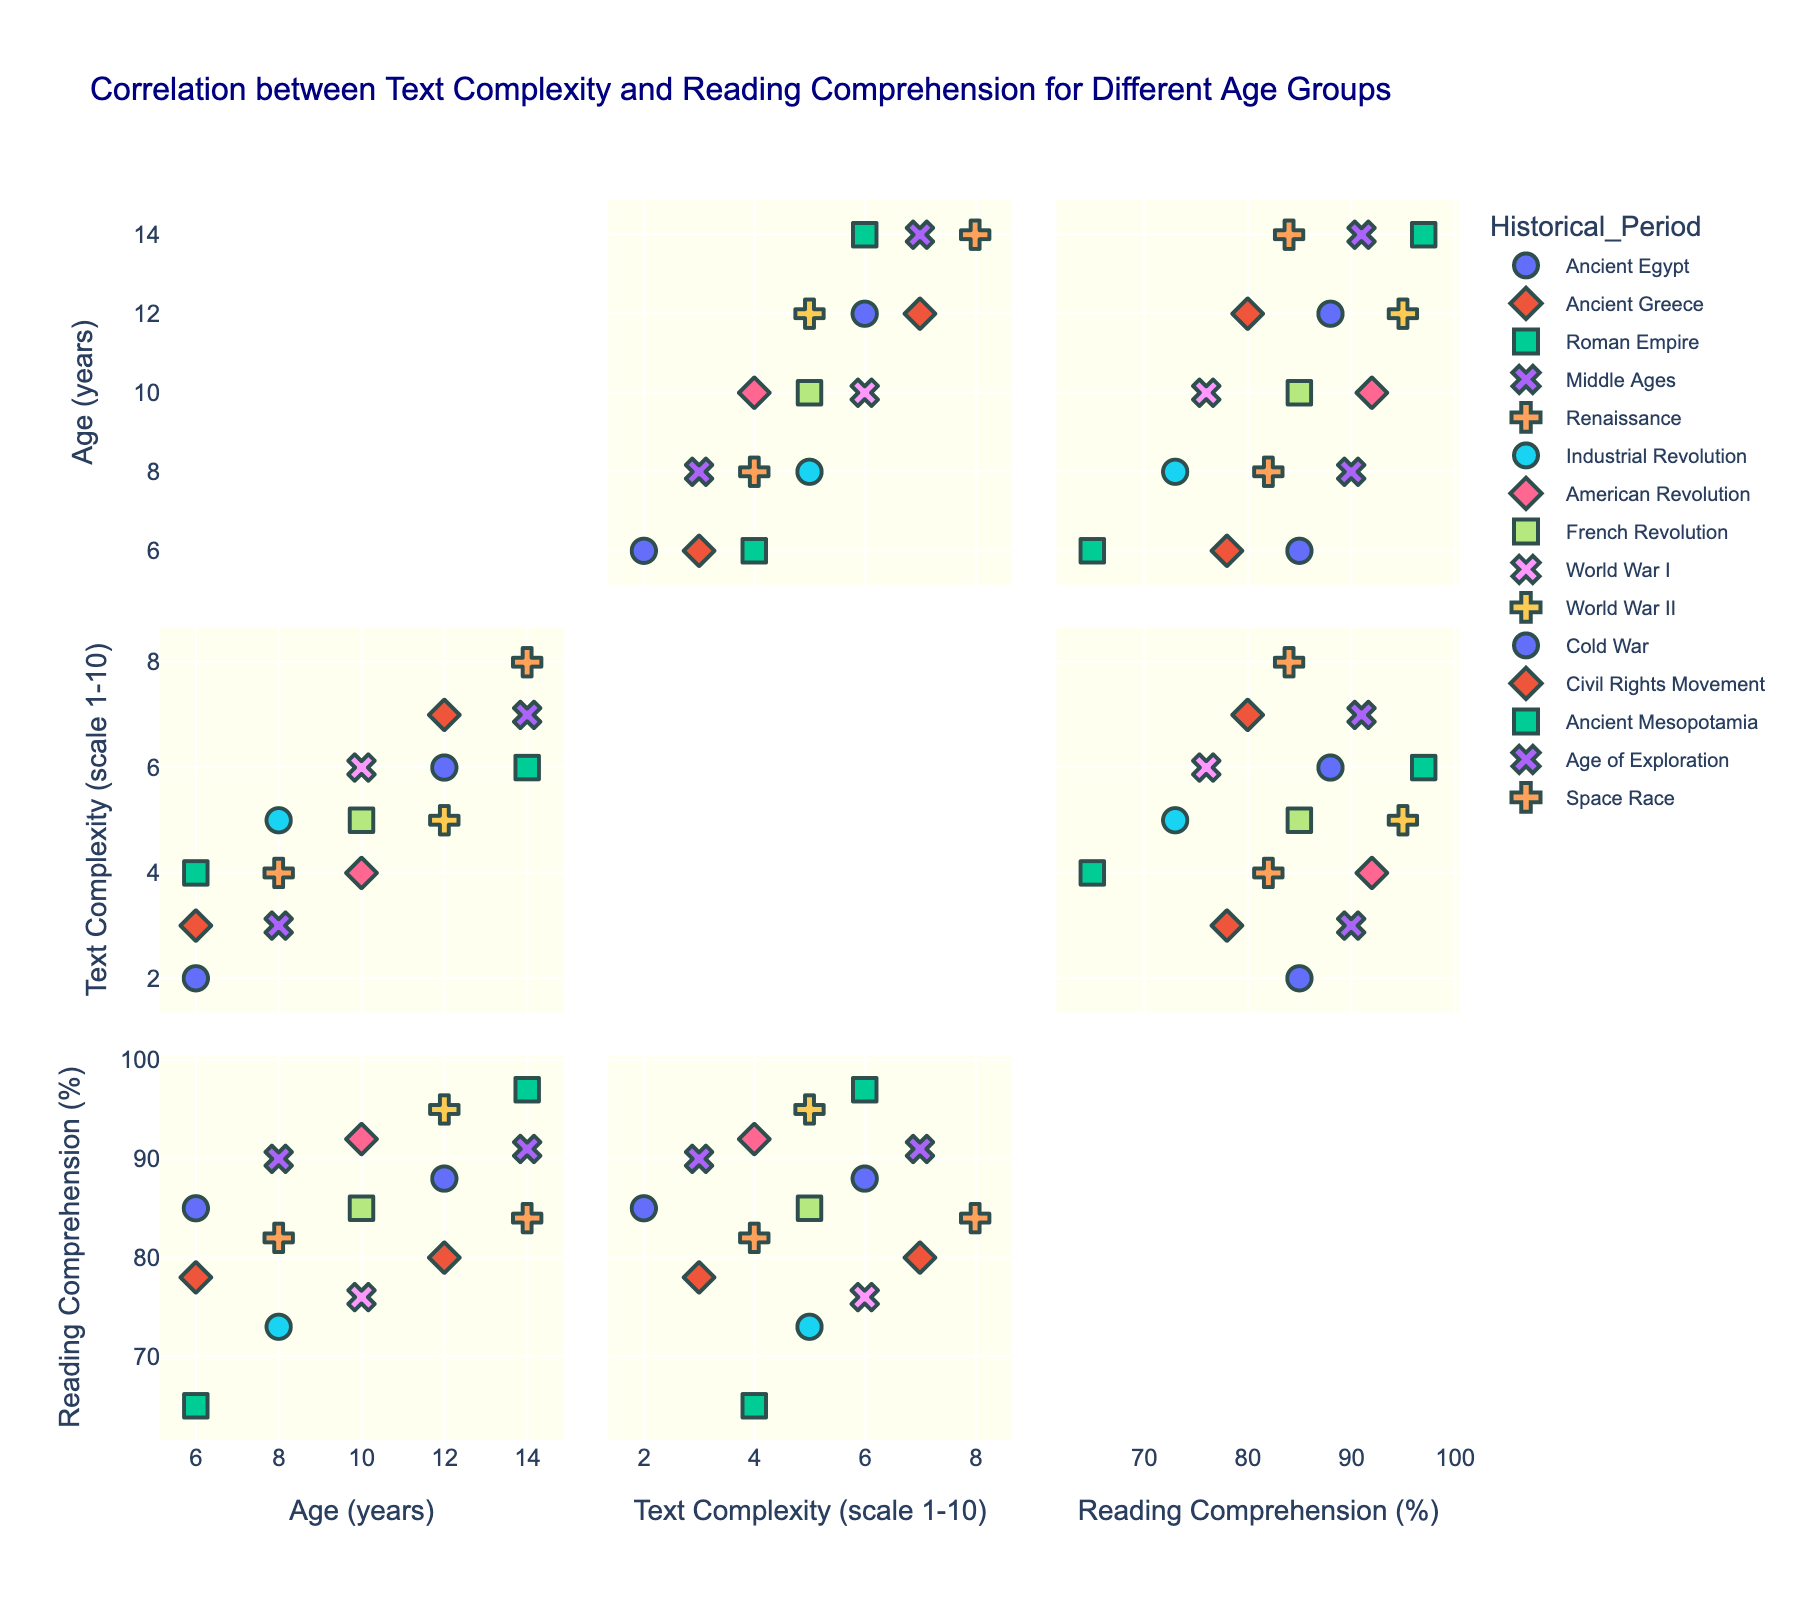How many different historical periods are displayed in the scatterplot matrix? By analyzing the legend or the markers in the scatterplot matrix, we can count the unique historical periods.
Answer: 12 Which age group has the highest average text complexity? To determine this, we need to find the average text complexity for each age group listed in the data and compare these averages. The sums of text complexity for ages 6, 8, 10, 12, and 14 are 9, 12, 15, 18, and 21 respectively. Dividing by the number of data points (3 for each age group), we get averages of 3, 4, 5, 6, and 7 respectively. The highest average is for age 14.
Answer: 14 Is there a trend between text complexity and reading comprehension as age increases? Observing the scatterplot matrix, we can see if there's an upward or downward trend in reading comprehension with respect to text complexity for different ages. Generally, as age increases, both text complexity and reading comprehension appear to increase.
Answer: Yes, both increase Which historical period is associated with the highest reading comprehension score? By examining the specific markers in the scatterplot matrix that represent the reading comprehension scores, we find the highest reading comprehension value and identify the corresponding historical period in the legend.
Answer: Ancient Mesopotamia What is the range of reading comprehension scores for age 8? The range can be found by identifying the highest and lowest reading comprehension scores for the age 8 group, then calculating the difference. The scores for age 8 are 90, 82, and 73, so the range is 90 - 73.
Answer: 17 How does the reading comprehension for the Industrial Revolution compare to the Space Race? By locating both historical periods in the scatterplot matrix and comparing their reading comprehension values, we find the values for Industrial Revolution (73) and Space Race (84).
Answer: Space Race is higher Do text complexity and reading comprehension always increase together for each age? By examining the scatterplot points and looking at the combinations of text complexity and reading comprehension scores for each age, we can assess if they consistently increase together. For example, ages 8 and 12 show an increase in both, but ages 10 and 14 do not always increase at the same rate.
Answer: No What is the average reading comprehension score for age 10? The scores for age 10 are 92, 85, and 76. Adding these up gives 253, and dividing by 3 gives an average of 253 / 3.
Answer: 84.33 Which age group shows the greatest variance in reading comprehension scores? To find this, we have to calculate the variance of reading comprehension for each age group. Variance is determined by finding the average of the squared differences from the mean. Visually, we can estimate variance by observing the spread of scores in the scatterplot matrix. Age 10 with scores 92, 85, and 76 appears to have the greatest spread.
Answer: Age 10 Is there any historical period where reading comprehension exceeds 90% for ages 12 and 14? Check the reading comprehension scores for both age groups 12 and 14 across all historical periods to see if any score exceeds 90%. We find that the reading comprehension for the Cold War (88) for age 12 and Civil Rights Movement (80) for age 12 do not exceed 90%, while for age 14, Ancient Mesopotamia (97) and Age of Exploration (91) do exceed 90%.
Answer: Yes, Ancient Mesopotamia and Age of Exploration 